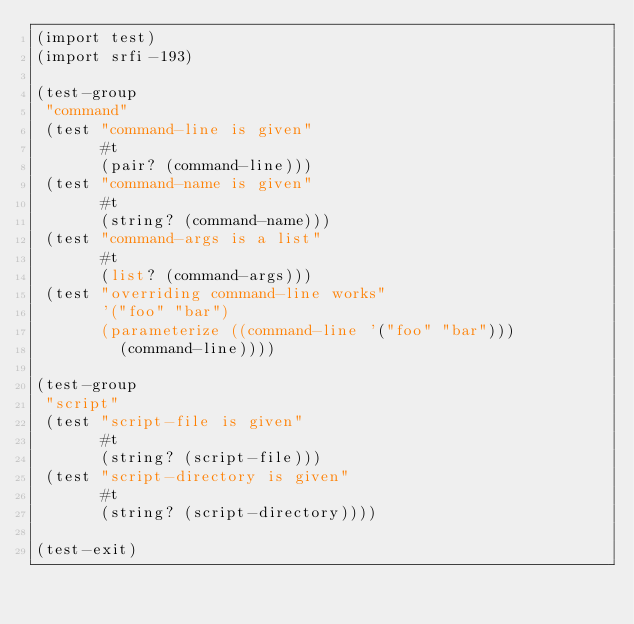Convert code to text. <code><loc_0><loc_0><loc_500><loc_500><_Scheme_>(import test)
(import srfi-193)

(test-group
 "command"
 (test "command-line is given"
       #t
       (pair? (command-line)))
 (test "command-name is given"
       #t
       (string? (command-name)))
 (test "command-args is a list"
       #t
       (list? (command-args)))
 (test "overriding command-line works"
       '("foo" "bar")
       (parameterize ((command-line '("foo" "bar")))
         (command-line))))

(test-group
 "script"
 (test "script-file is given"
       #t
       (string? (script-file)))
 (test "script-directory is given"
       #t
       (string? (script-directory))))

(test-exit)
</code> 